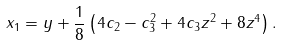Convert formula to latex. <formula><loc_0><loc_0><loc_500><loc_500>x _ { 1 } = y + \frac { 1 } { 8 } \left ( 4 c _ { 2 } - c _ { 3 } ^ { 2 } + 4 c _ { 3 } z ^ { 2 } + 8 z ^ { 4 } \right ) .</formula> 